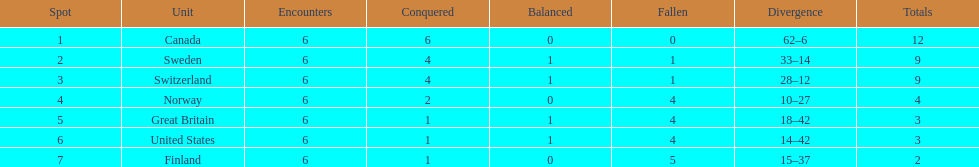How many teams won at least 2 games throughout the 1951 world ice hockey championships? 4. 